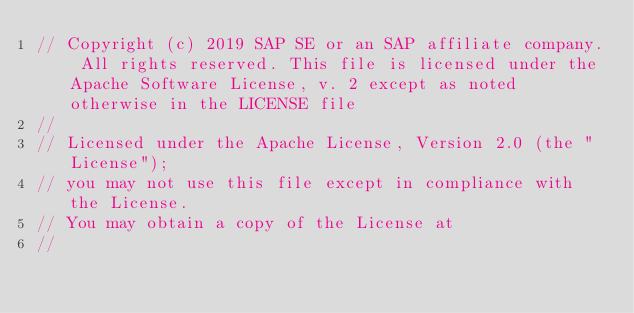<code> <loc_0><loc_0><loc_500><loc_500><_Go_>// Copyright (c) 2019 SAP SE or an SAP affiliate company. All rights reserved. This file is licensed under the Apache Software License, v. 2 except as noted otherwise in the LICENSE file
//
// Licensed under the Apache License, Version 2.0 (the "License");
// you may not use this file except in compliance with the License.
// You may obtain a copy of the License at
//</code> 